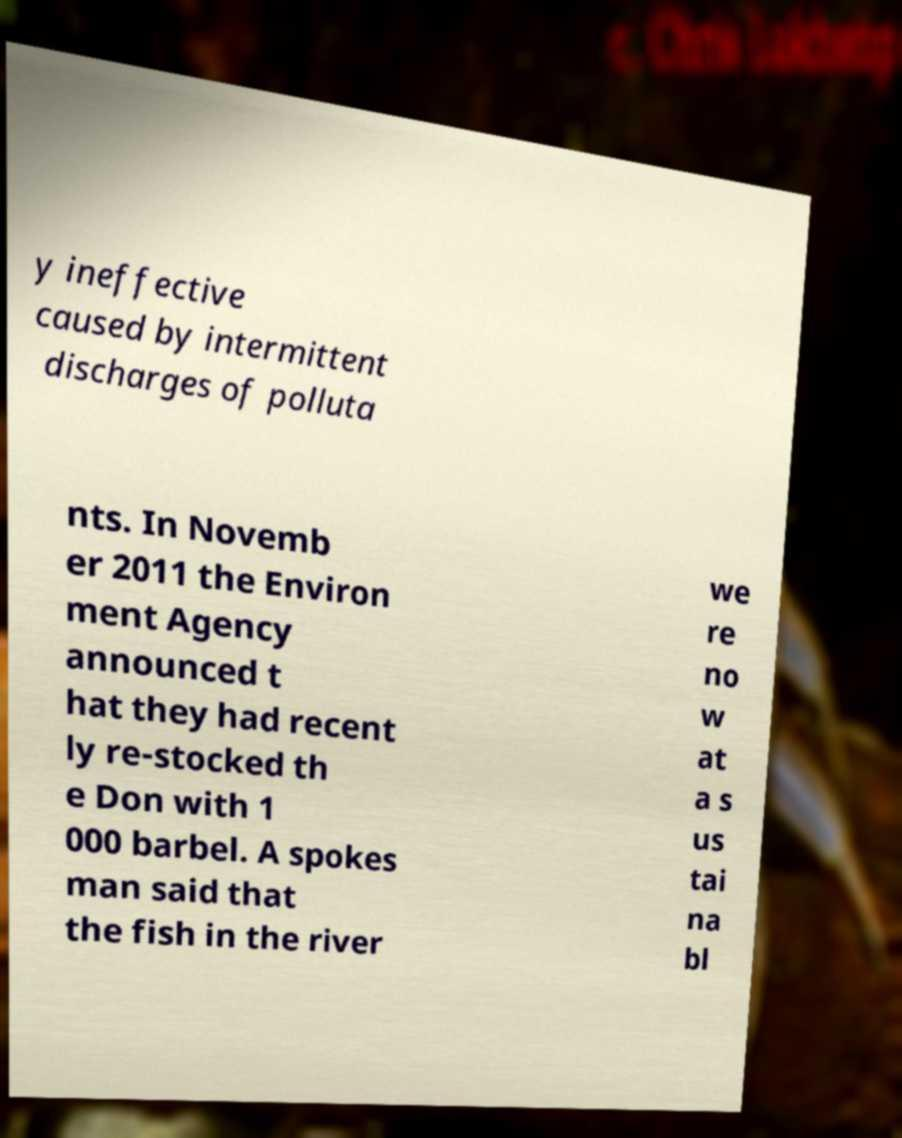Can you accurately transcribe the text from the provided image for me? y ineffective caused by intermittent discharges of polluta nts. In Novemb er 2011 the Environ ment Agency announced t hat they had recent ly re-stocked th e Don with 1 000 barbel. A spokes man said that the fish in the river we re no w at a s us tai na bl 